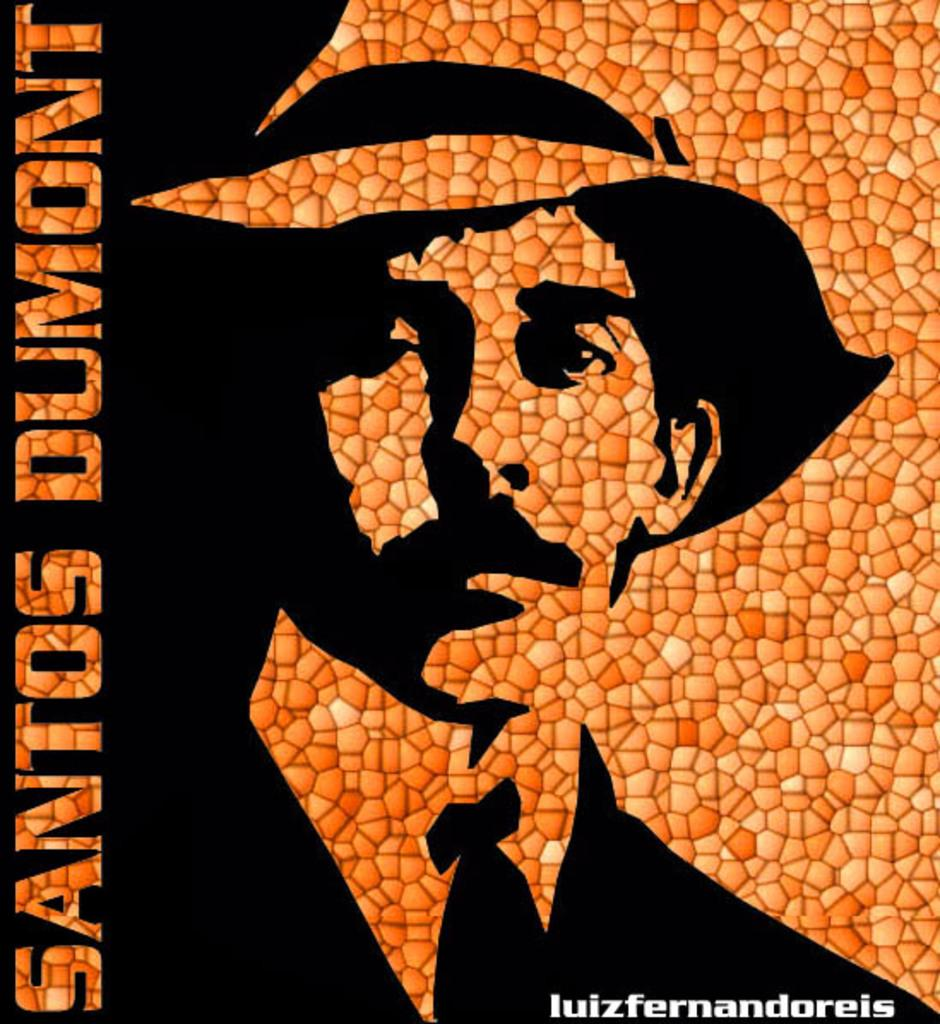<image>
Offer a succinct explanation of the picture presented. An ad or poster of santos dumont, his pictures seems to be made using different textures. 